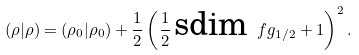<formula> <loc_0><loc_0><loc_500><loc_500>( \rho | \rho ) = ( \rho _ { 0 } | \rho _ { 0 } ) + \frac { 1 } { 2 } \left ( \frac { 1 } { 2 } \, \text {sdim} \ f g _ { 1 / 2 } + 1 \right ) ^ { 2 } .</formula> 